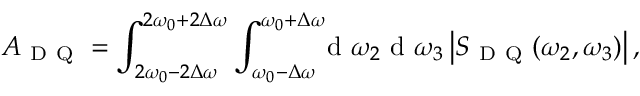<formula> <loc_0><loc_0><loc_500><loc_500>A _ { D Q } = \int _ { 2 \omega _ { 0 } - 2 \Delta \omega } ^ { 2 \omega _ { 0 } + 2 \Delta \omega } \int _ { \omega _ { 0 } - \Delta \omega } ^ { \omega _ { 0 } + \Delta \omega } \, { d } \omega _ { 2 } { d } \omega _ { 3 } \left | S _ { D Q } ( \omega _ { 2 } , \omega _ { 3 } ) \right | ,</formula> 